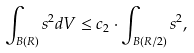<formula> <loc_0><loc_0><loc_500><loc_500>\int _ { B ( R ) } s ^ { 2 } d V \leq c _ { 2 } \cdot \int _ { B ( R / 2 ) } s ^ { 2 } ,</formula> 